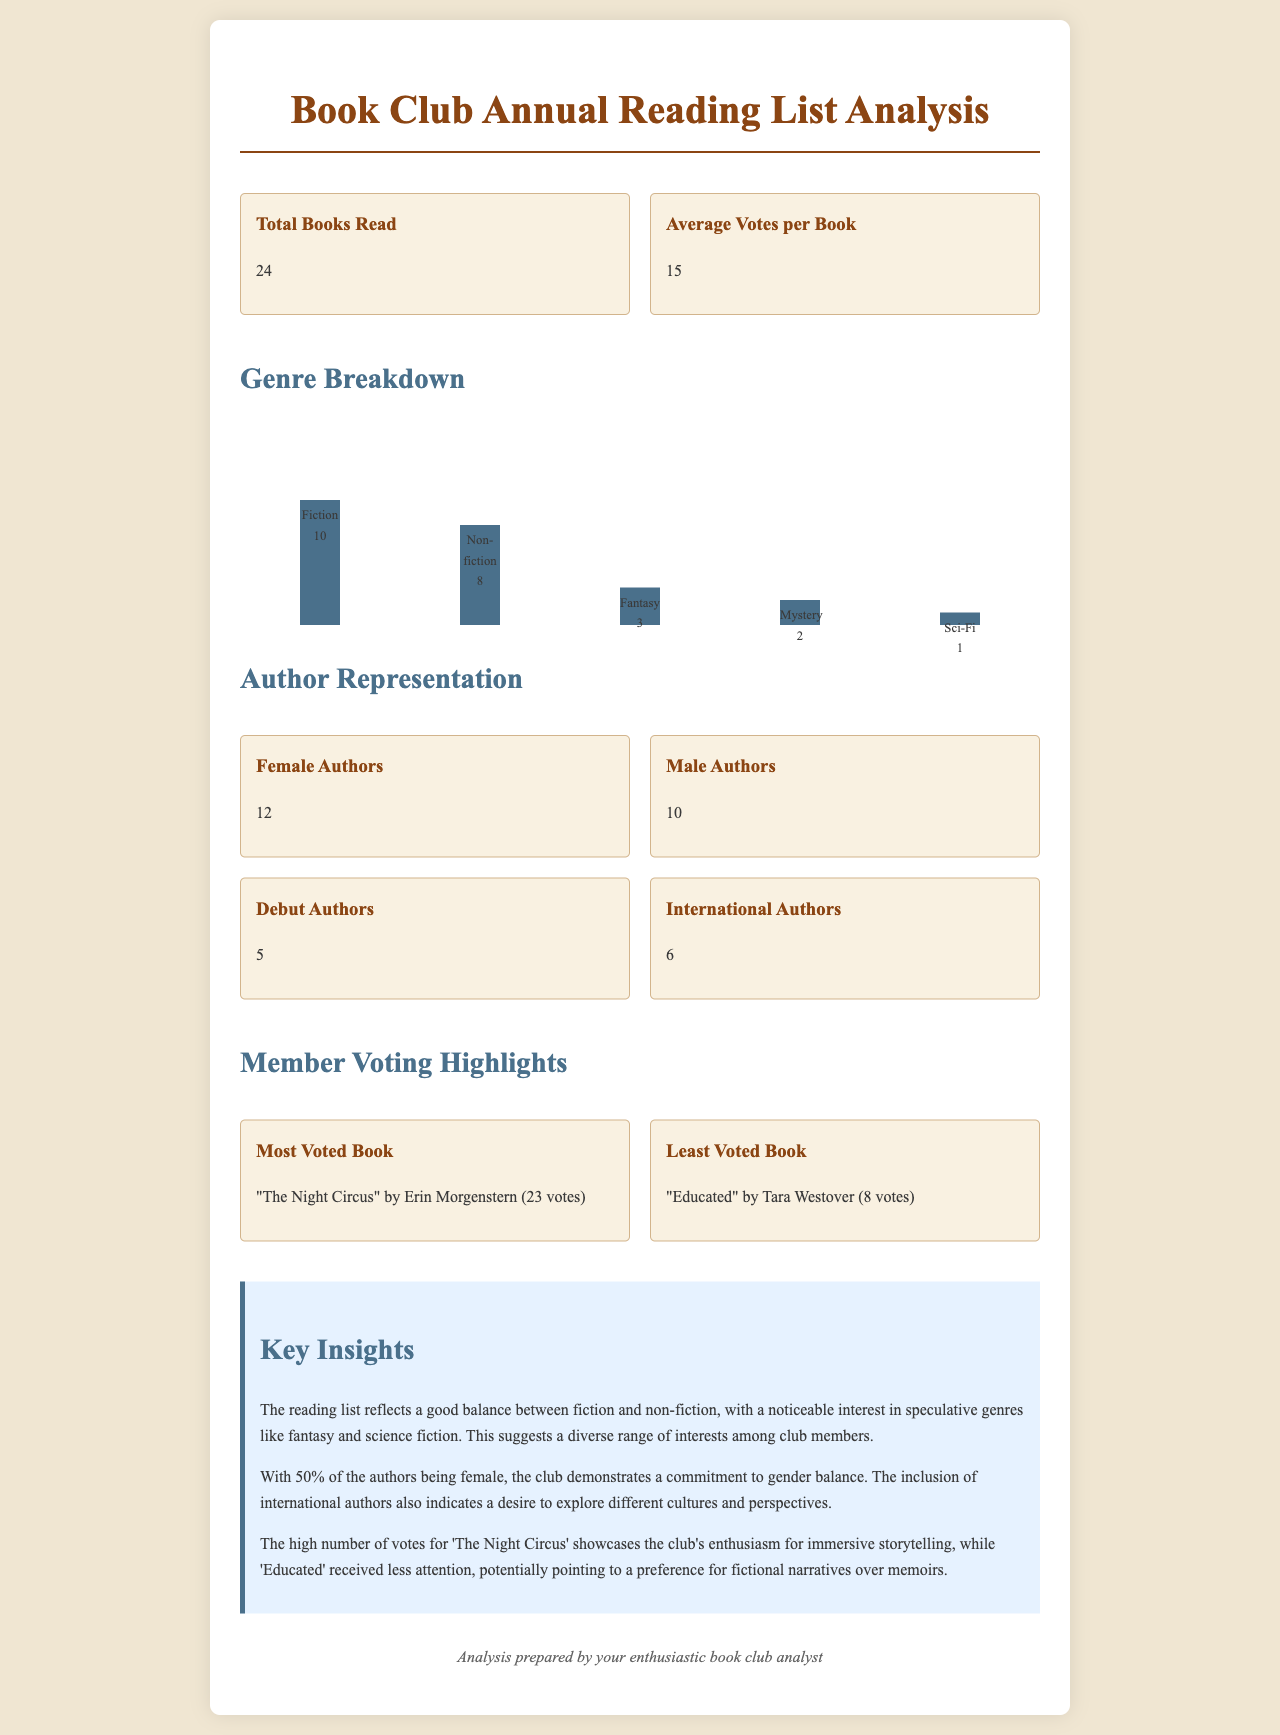What is the total number of books read? The total number of books read is specified in the document under "Total Books Read," which states 24.
Answer: 24 How many female authors were represented? The number of female authors can be found in the "Author Representation" section where it states 12 female authors.
Answer: 12 What genre had the most books read? The genre with the most books read is indicated in the "Genre Breakdown" section, which lists 10 books in the Fiction category as the highest.
Answer: Fiction How many international authors were included? The document provides this information in the "Author Representation" section stating there were 6 international authors.
Answer: 6 What was the average number of votes per book? The average number of votes per book is given in the document under "Average Votes per Book," which is 15.
Answer: 15 Which book received the highest number of votes? The book with the highest number of votes is mentioned as "The Night Circus" by Erin Morgenstern with 23 votes.
Answer: "The Night Circus" by Erin Morgenstern What percentage of the authors were male? The document states there are 10 male authors out of a total of 22 (12 female + 10 male), which means approximately 45.45%.
Answer: 45.45% What insight is provided about member preferences? The insights section highlights preferences, specifically pointing to "a preference for fictional narratives over memoirs."
Answer: Preference for fictional narratives over memoirs How many books were categorized as Sc-Fi? The number of Sci-Fi books is mentioned in the "Genre Breakdown" section as 1.
Answer: 1 